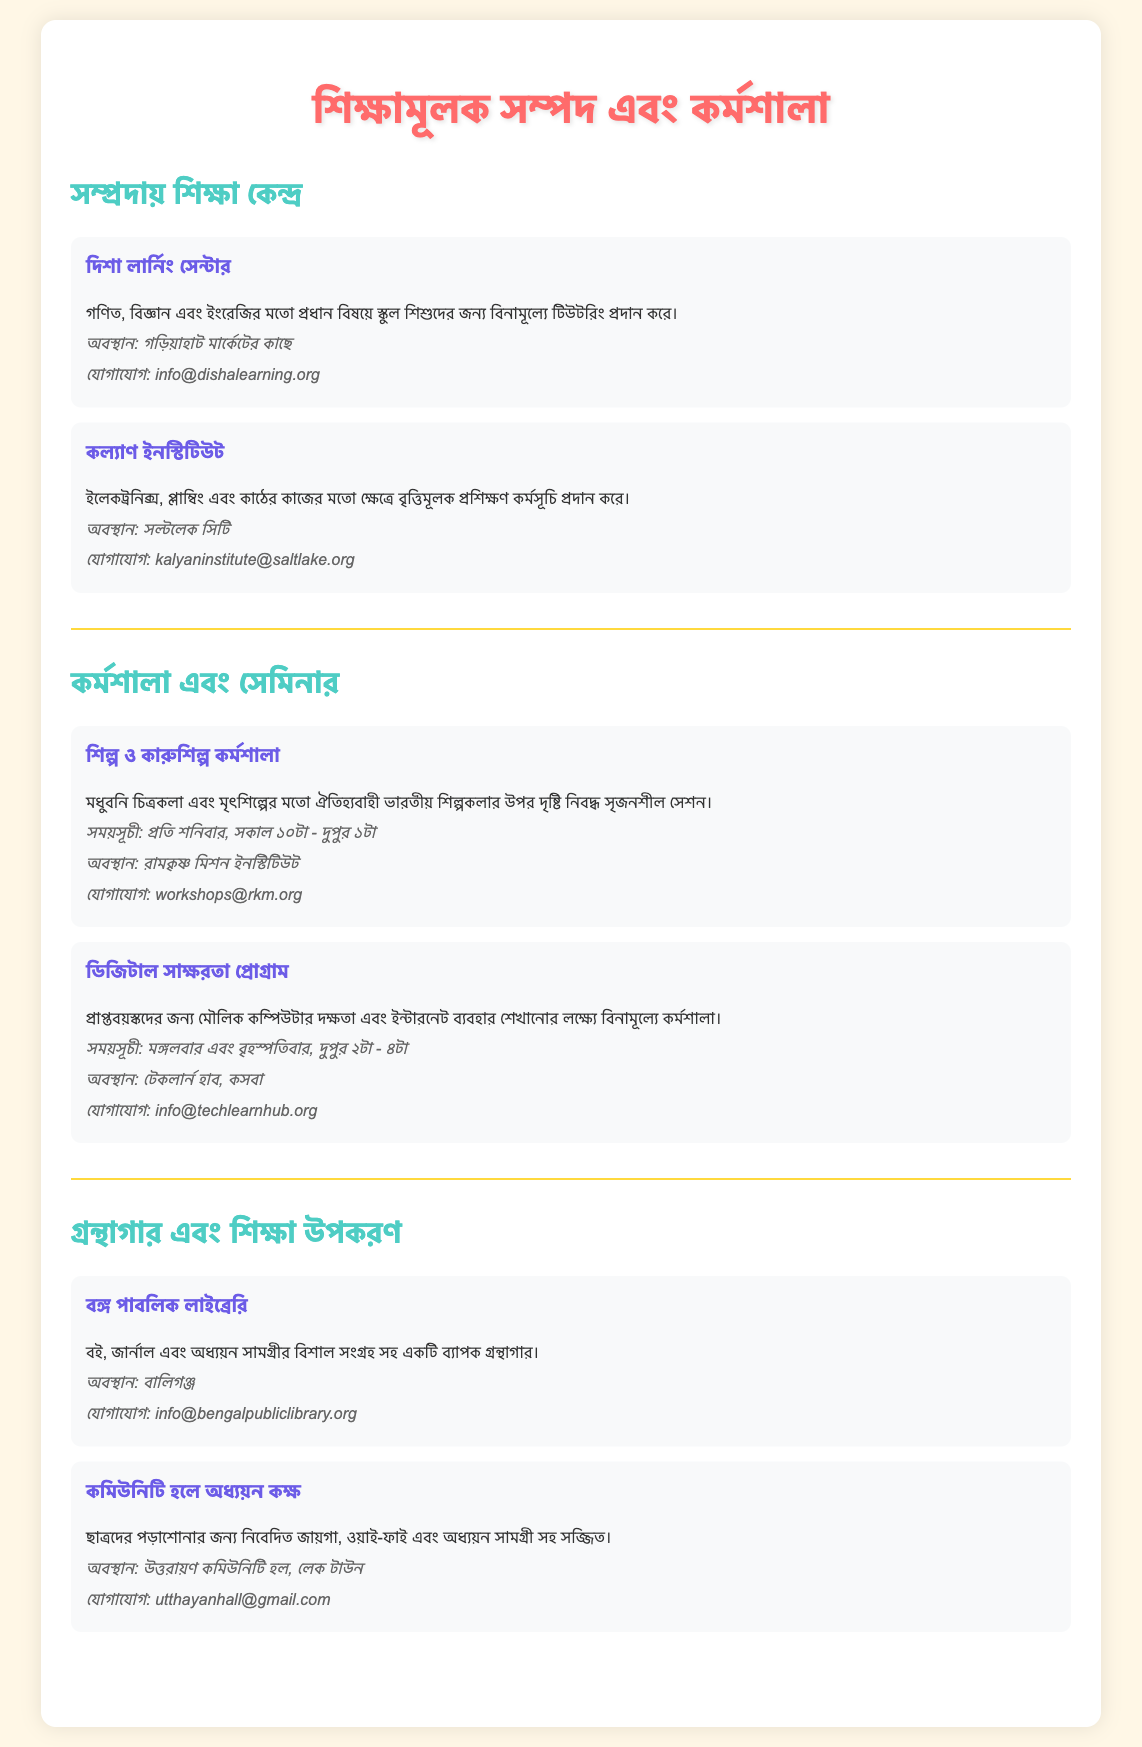What is the name of the community education center? The name of the community education center is mentioned in the document as "দিশা লার্নিং সেন্টার".
Answer: দিশা লার্নিং সেন্টার What subjects does Disha Learning Center offer tutoring in? The document specifies that Disha Learning Center provides tutoring in subjects like mathematics, science, and English.
Answer: গণিত, বিজ্ঞান এবং ইংরেজি Which institute offers vocational training programs? The document states that "কল্যাণ ইনস্টিটিউট" offers vocational training programs.
Answer: কল্যাণ ইনস্টিটিউট When do the arts and crafts workshops take place? The document provides the schedule for the arts and crafts workshops as every Saturday from 10 AM to 1 PM.
Answer: প্রতি শনিবার, সকাল ১০টা - দুপুর ১টা Where is the Bengal Public Library located? The location of the Bengal Public Library, as mentioned in the document, is at "বালিগঞ্জ".
Answer: বালিগঞ্জ What type of program is offered at TechLearn Hub? The document describes the program at TechLearn Hub as a digital literacy program for adults.
Answer: ডিজিটাল সাক্ষরতা প্রোগ্রাম How can one contact Disha Learning Center? The contact information provided in the document for Disha Learning Center is "info@dishalearning.org".
Answer: info@dishalearning.org What is available in the Study Room of the Community Hall? The document mentions that the Study Room is equipped with Wi-Fi and study materials.
Answer: ওয়াই-ফাই এবং অধ্যয়ন সামগ্রী What kind of art is the arts and crafts workshop focused on? The document specifies that the arts and crafts workshop focuses on traditional Indian art forms.
Answer: ঐতিহ্যবাহী ভারতীয় শিল্পকলার 